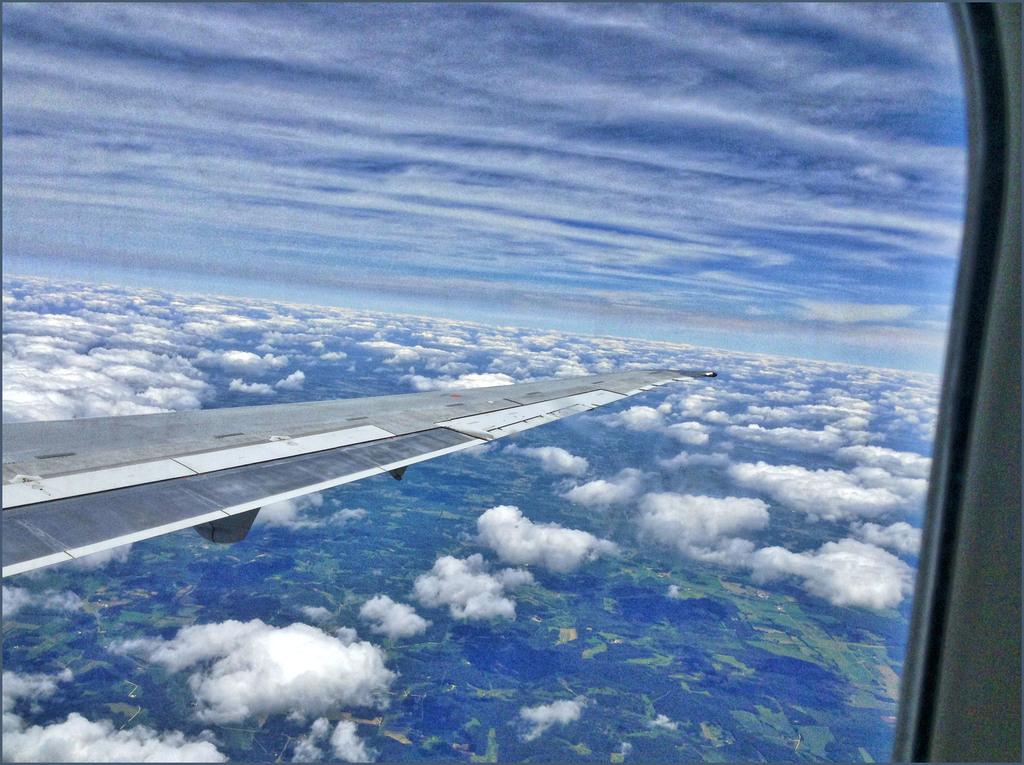Could you give a brief overview of what you see in this image? In this image there is a flight wing and a glass window through that window clouds are visible. 